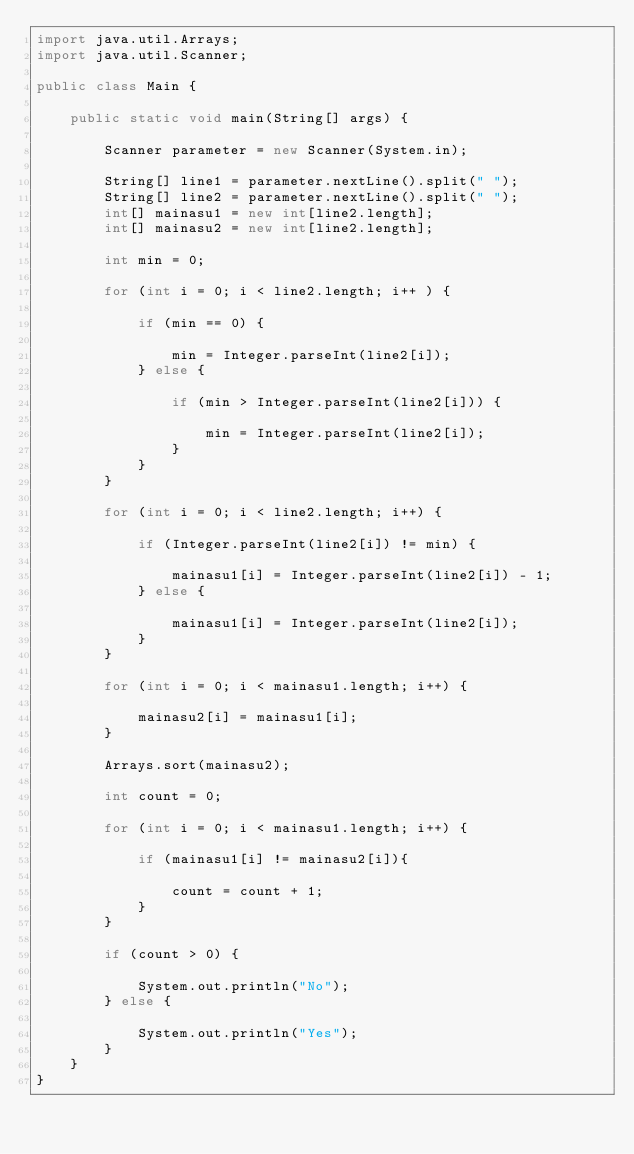Convert code to text. <code><loc_0><loc_0><loc_500><loc_500><_Java_>import java.util.Arrays;
import java.util.Scanner;

public class Main {

    public static void main(String[] args) {

    	Scanner parameter = new Scanner(System.in);

    	String[] line1 = parameter.nextLine().split(" ");
        String[] line2 = parameter.nextLine().split(" ");
        int[] mainasu1 = new int[line2.length];
        int[] mainasu2 = new int[line2.length];

        int min = 0;

        for (int i = 0; i < line2.length; i++ ) {

        	if (min == 0) {

        		min = Integer.parseInt(line2[i]);
        	} else {

        		if (min > Integer.parseInt(line2[i])) {

        			min = Integer.parseInt(line2[i]);
        		}
        	}
        }

        for (int i = 0; i < line2.length; i++) {

        	if (Integer.parseInt(line2[i]) != min) {

        		mainasu1[i] = Integer.parseInt(line2[i]) - 1;
        	} else {

        		mainasu1[i] = Integer.parseInt(line2[i]);
        	}
        }

        for (int i = 0; i < mainasu1.length; i++) {

        	mainasu2[i] = mainasu1[i];
        }

        Arrays.sort(mainasu2);

        int count = 0;

        for (int i = 0; i < mainasu1.length; i++) {

        	if (mainasu1[i] != mainasu2[i]){

        		count = count + 1;
        	}
        }

        if (count > 0) {

        	System.out.println("No");
        } else {

        	System.out.println("Yes");
        }
    }
}
</code> 